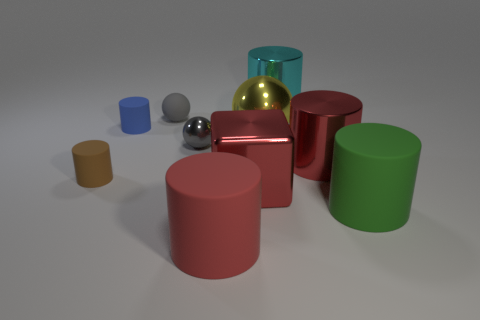What shape is the tiny object that is the same material as the red cube? The tiny object with the same material as the red cube is a sphere, showcasing a perfectly round three-dimensional shape that reflects light similarly to the red cube's glossy surface. 